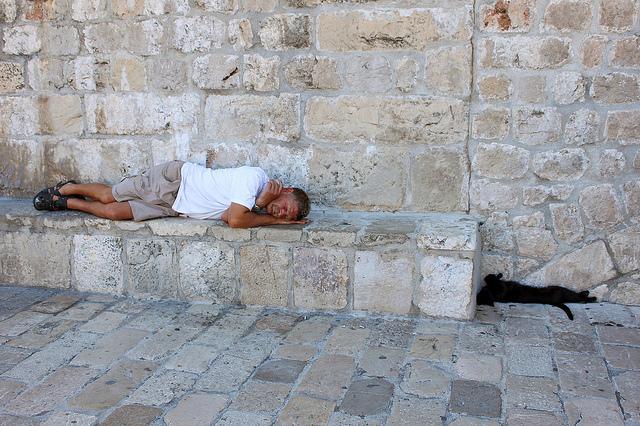What is on the person's feet?
Quick response, please. Sandals. What type of animal?
Answer briefly. Cat. Are these walls bullet-proof?
Write a very short answer. Yes. What is sleeping to the right?
Write a very short answer. Cat. What color is the cat?
Short answer required. Black. 